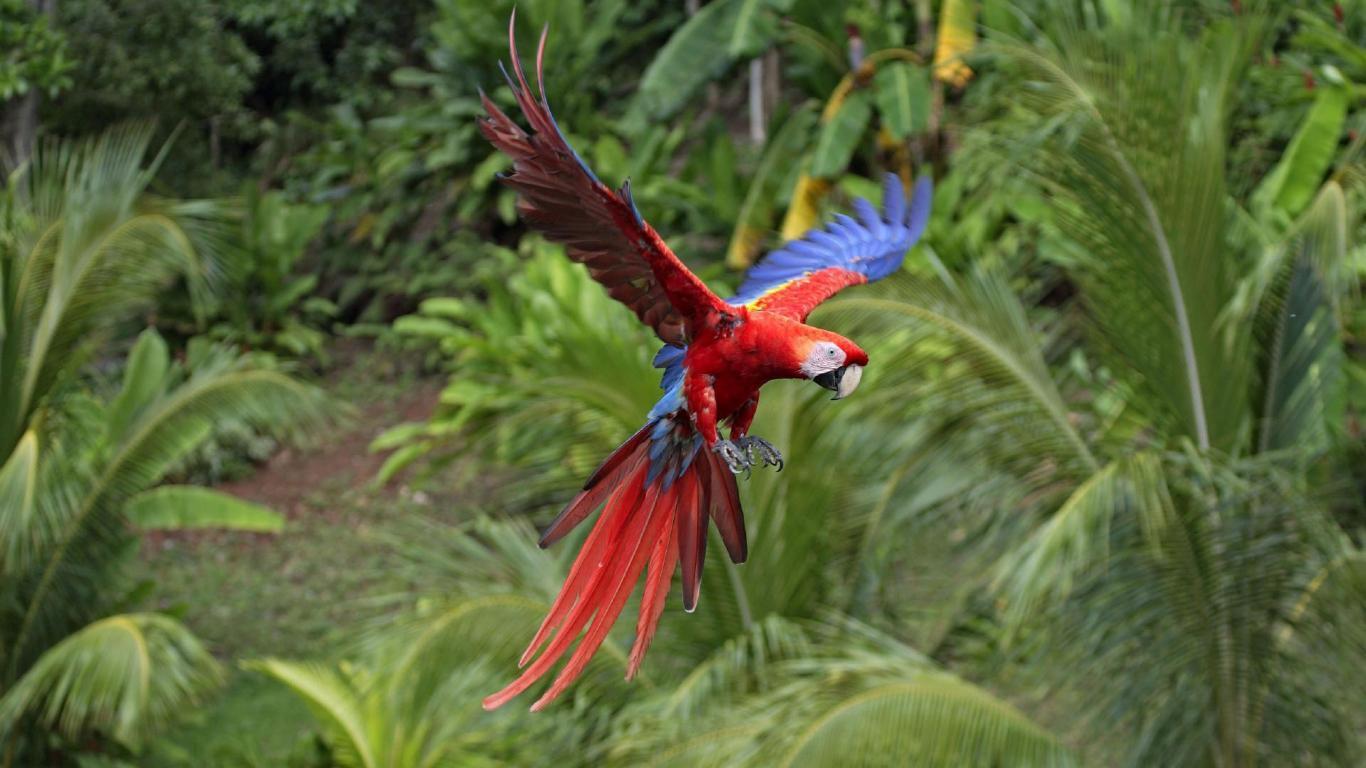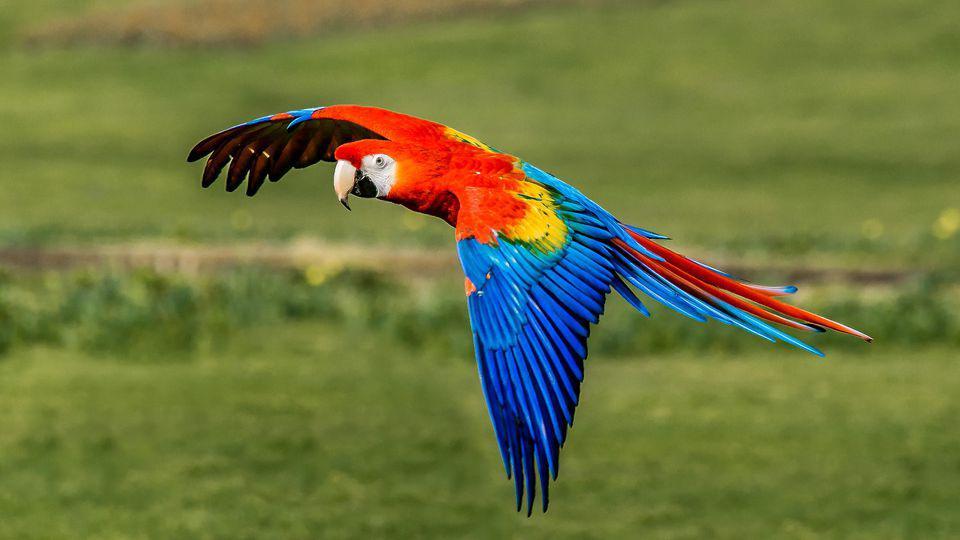The first image is the image on the left, the second image is the image on the right. Analyze the images presented: Is the assertion "At least one of the birds is flying." valid? Answer yes or no. Yes. 